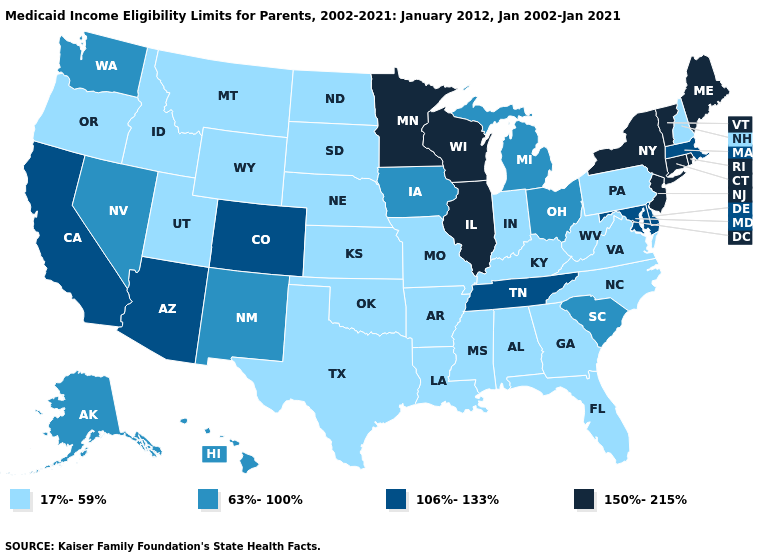Does Pennsylvania have the same value as Nevada?
Give a very brief answer. No. Name the states that have a value in the range 63%-100%?
Give a very brief answer. Alaska, Hawaii, Iowa, Michigan, Nevada, New Mexico, Ohio, South Carolina, Washington. Name the states that have a value in the range 106%-133%?
Write a very short answer. Arizona, California, Colorado, Delaware, Maryland, Massachusetts, Tennessee. What is the value of North Carolina?
Short answer required. 17%-59%. Does Colorado have the lowest value in the West?
Be succinct. No. Which states hav the highest value in the Northeast?
Be succinct. Connecticut, Maine, New Jersey, New York, Rhode Island, Vermont. Which states have the highest value in the USA?
Quick response, please. Connecticut, Illinois, Maine, Minnesota, New Jersey, New York, Rhode Island, Vermont, Wisconsin. What is the value of Virginia?
Short answer required. 17%-59%. What is the value of Wyoming?
Be succinct. 17%-59%. What is the value of Massachusetts?
Write a very short answer. 106%-133%. Does Indiana have the lowest value in the MidWest?
Answer briefly. Yes. Does Ohio have the lowest value in the USA?
Short answer required. No. Name the states that have a value in the range 17%-59%?
Concise answer only. Alabama, Arkansas, Florida, Georgia, Idaho, Indiana, Kansas, Kentucky, Louisiana, Mississippi, Missouri, Montana, Nebraska, New Hampshire, North Carolina, North Dakota, Oklahoma, Oregon, Pennsylvania, South Dakota, Texas, Utah, Virginia, West Virginia, Wyoming. Name the states that have a value in the range 150%-215%?
Answer briefly. Connecticut, Illinois, Maine, Minnesota, New Jersey, New York, Rhode Island, Vermont, Wisconsin. 